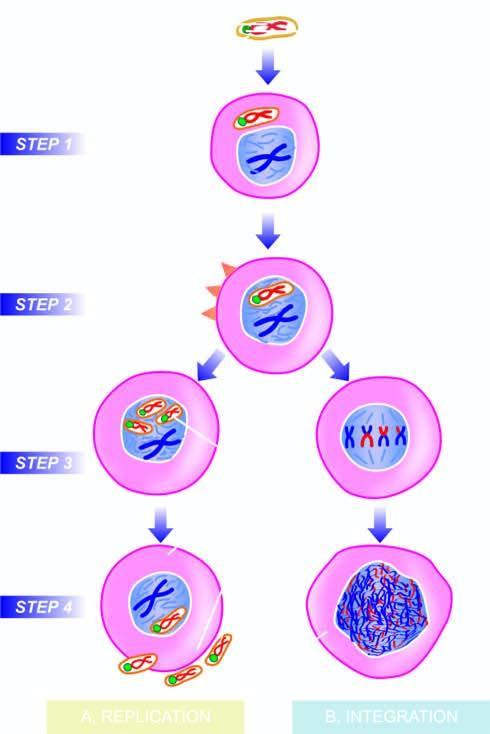does the dna virus invade the host cell?
Answer the question using a single word or phrase. Yes 